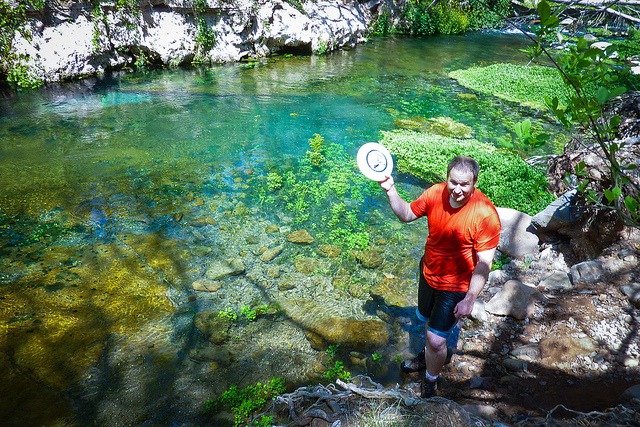How many elephants are behind the fence? Upon review of the image, there are no elephants visible; the natural setting includes clear water and vegetation but no elephants or fences in sight. 